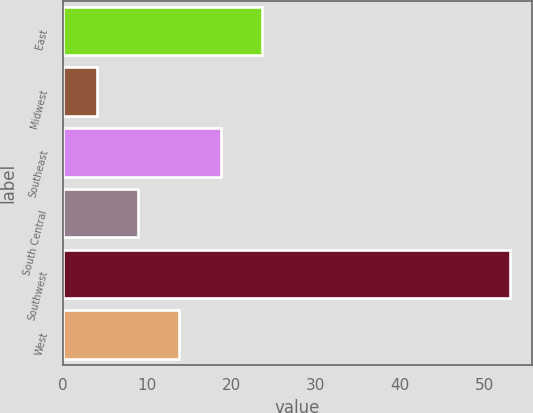<chart> <loc_0><loc_0><loc_500><loc_500><bar_chart><fcel>East<fcel>Midwest<fcel>Southeast<fcel>South Central<fcel>Southwest<fcel>West<nl><fcel>23.6<fcel>4<fcel>18.7<fcel>8.9<fcel>53<fcel>13.8<nl></chart> 